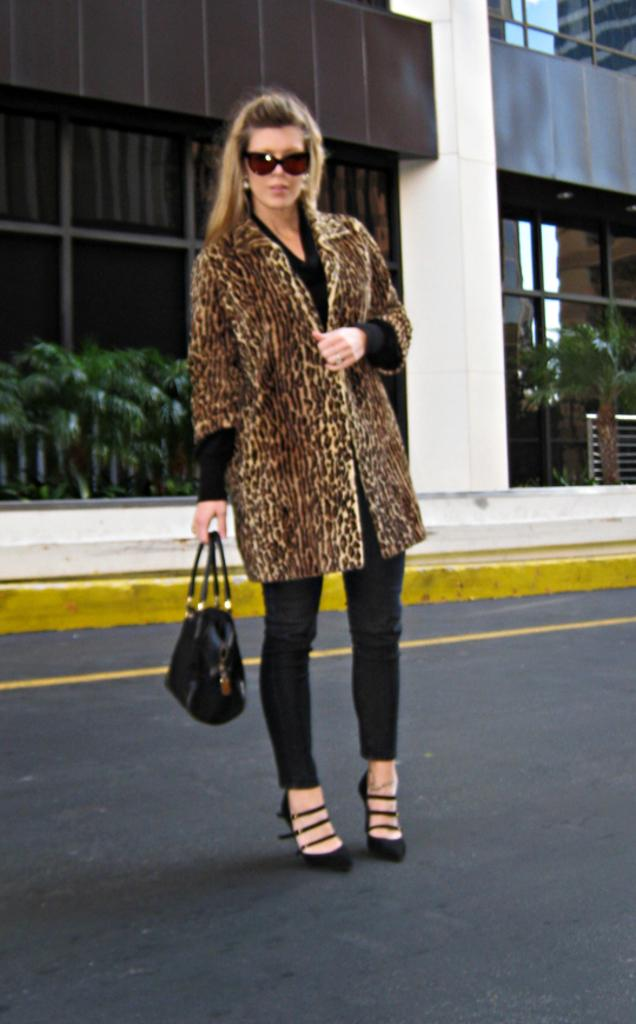Who is present in the image? There is a woman in the image. What is the woman doing in the image? The woman is standing on the road. What is the woman wearing in the image? The woman is wearing a brown coat. What is the woman holding in the image? The woman is holding a bag. What can be seen in the background of the image? There is a wall in the background of the image. What is the color of the wall in the image? The wall is in brown color. What type of market can be seen in the image? There is no market present in the image; it features a woman standing on the road with a brown coat and a bag, and a brown wall in the background. Is there a battle taking place in the image? No, there is no battle depicted in the image. 